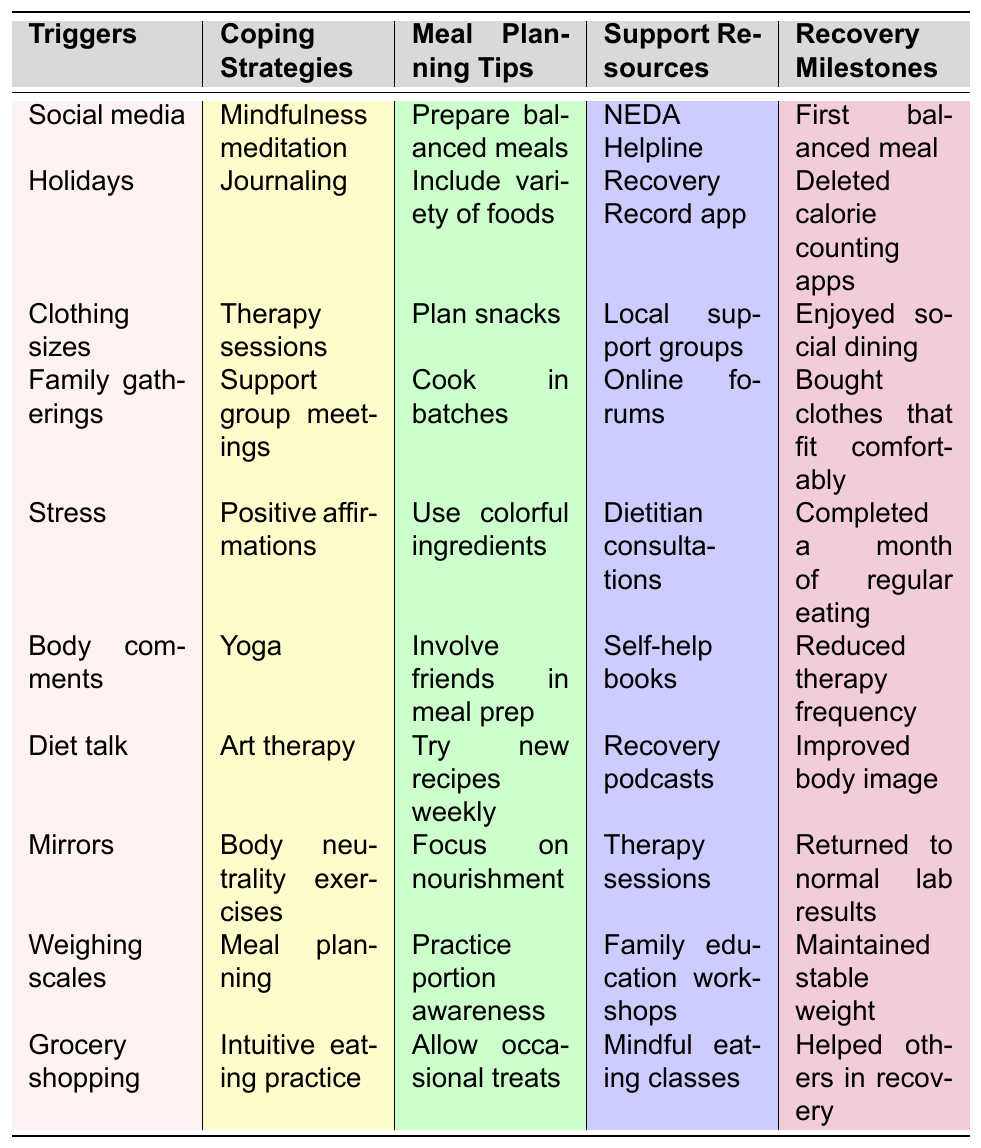What are some common triggers for eating disorders listed in the table? The table lists several triggers such as social media, holidays, clothing sizes, family gatherings, stress, body comments, diet talk, mirrors, weighing scales, and grocery shopping.
Answer: Social media, holidays, clothing sizes, family gatherings, stress, body comments, diet talk, mirrors, weighing scales, grocery shopping Which coping strategy is paired with diet talk? By examining the table, diet talk corresponds to art therapy as the coping strategy listed next to it.
Answer: Art therapy How many meal planning tips are provided in total? The table includes ten meal planning tips that can be counted directly: prepare balanced meals, include variety of foods, plan snacks, cook in batches, use colorful ingredients, involve friends in meal prep, try new recipes weekly, focus on nourishment, practice portion awareness, and allow occasional treats.
Answer: 10 Do any support resources specifically mention online assistance? Yes, the table lists online forums as a support resource, indicating that there are resources available for online assistance.
Answer: Yes What is one recovery milestone that involves a change in eating habits? The table indicates that "Completed a month of regular eating" is a recovery milestone highlighting a change in eating habits.
Answer: Completed a month of regular eating How many coping strategies are there associated with social media triggers and what are they? There is one coping strategy related to the trigger of social media, which is mindfulness meditation. The table clearly shows that this is the corresponding coping strategy.
Answer: 1: Mindfulness meditation Which meal planning tip focuses on ensuring meals consist of a variety of nutrients? The meal planning tips include "Include variety of foods," which emphasizes the importance of nutritional diversity in meals.
Answer: Include variety of foods What is the relationship between stress and coping strategies according to the table? Stress is linked to positive affirmations as the corresponding coping strategy, suggesting that this strategy can help mitigate the impact of stress.
Answer: Positive affirmations How many triggers and coping strategies have the same index number in their respective columns? Both columns have 10 items; thus, they share the same index numbers from 1 to 10, meaning each trigger has a coping strategy paired with it on an equal level.
Answer: 10 Are there more meal planning tips than recovery milestones in the table? Yes, there are ten meal planning tips listed, while there are only ten recovery milestones provided. Therefore, they are equal in number.
Answer: No, they are equal 